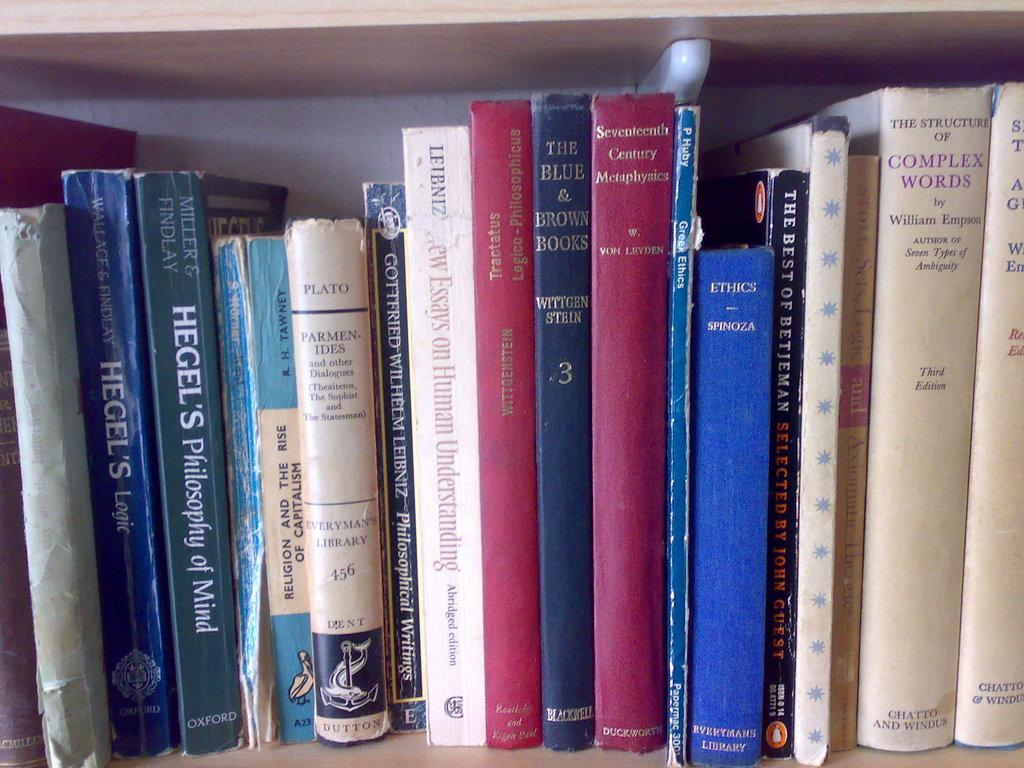<image>
Give a short and clear explanation of the subsequent image. Many books on a shelf one of which is Hegel's Philospohy of Mind. 